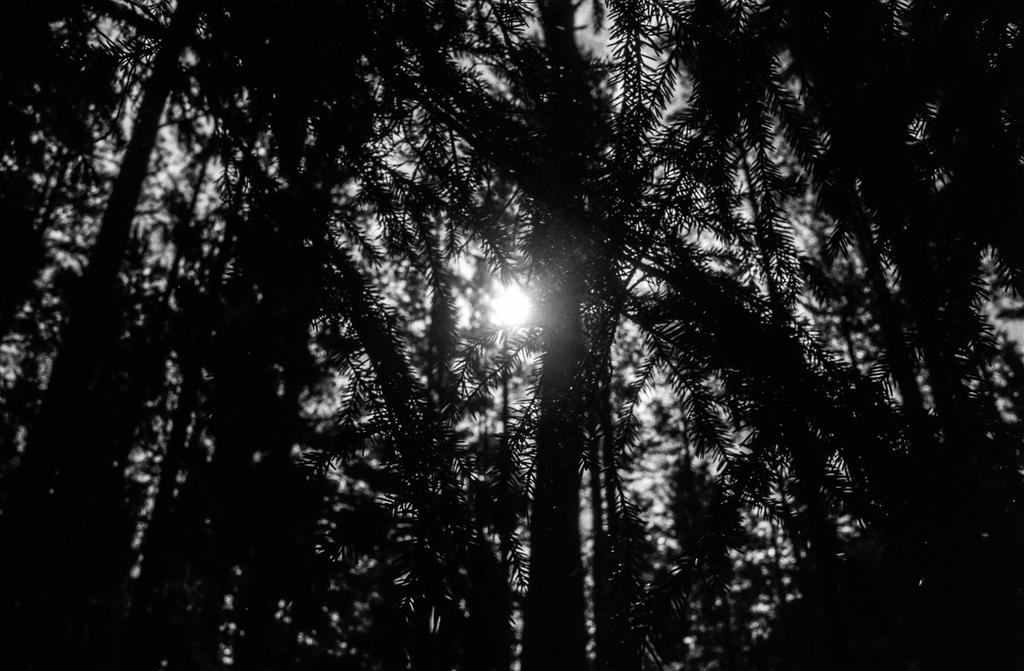Where was the image taken? The image was clicked outside. What can be seen in the background of the image? There are trees in the background of the image. What is visible in the sky in the image? The sky is visible in the image. Can you describe the lighting in the image? There is light in the image. What other objects can be seen in the image besides trees and the sky? There are other objects present in the image. What is the price of the hose in the image? There is no hose present in the image, so it is not possible to determine its price. 